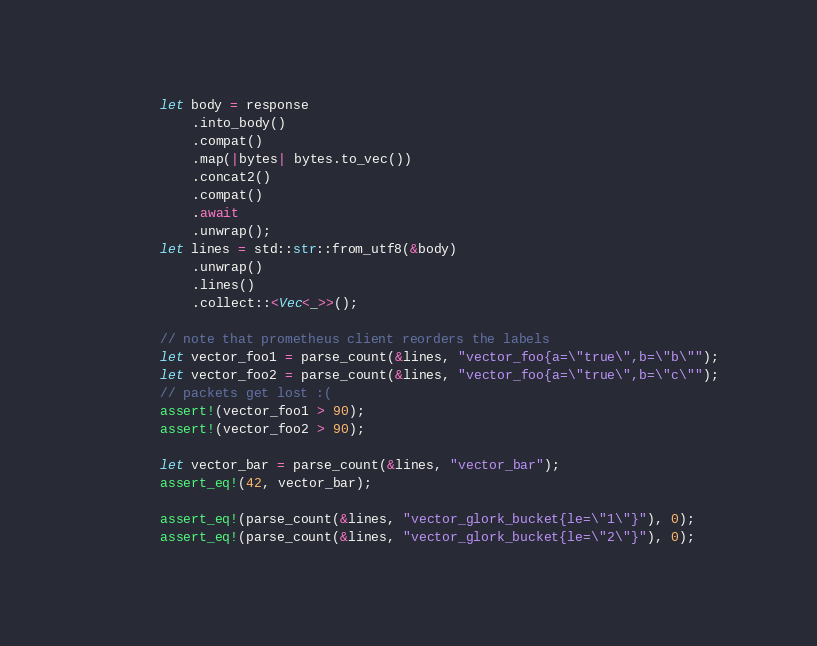<code> <loc_0><loc_0><loc_500><loc_500><_Rust_>        let body = response
            .into_body()
            .compat()
            .map(|bytes| bytes.to_vec())
            .concat2()
            .compat()
            .await
            .unwrap();
        let lines = std::str::from_utf8(&body)
            .unwrap()
            .lines()
            .collect::<Vec<_>>();

        // note that prometheus client reorders the labels
        let vector_foo1 = parse_count(&lines, "vector_foo{a=\"true\",b=\"b\"");
        let vector_foo2 = parse_count(&lines, "vector_foo{a=\"true\",b=\"c\"");
        // packets get lost :(
        assert!(vector_foo1 > 90);
        assert!(vector_foo2 > 90);

        let vector_bar = parse_count(&lines, "vector_bar");
        assert_eq!(42, vector_bar);

        assert_eq!(parse_count(&lines, "vector_glork_bucket{le=\"1\"}"), 0);
        assert_eq!(parse_count(&lines, "vector_glork_bucket{le=\"2\"}"), 0);</code> 